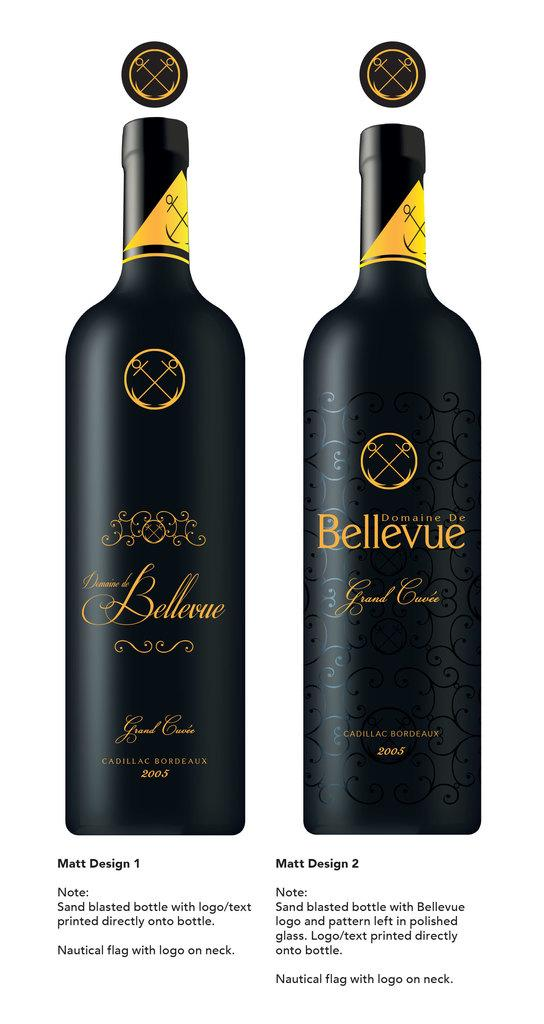<image>
Offer a succinct explanation of the picture presented. Matt designs 1 and 2 of a wine label are displayed next to each other. 